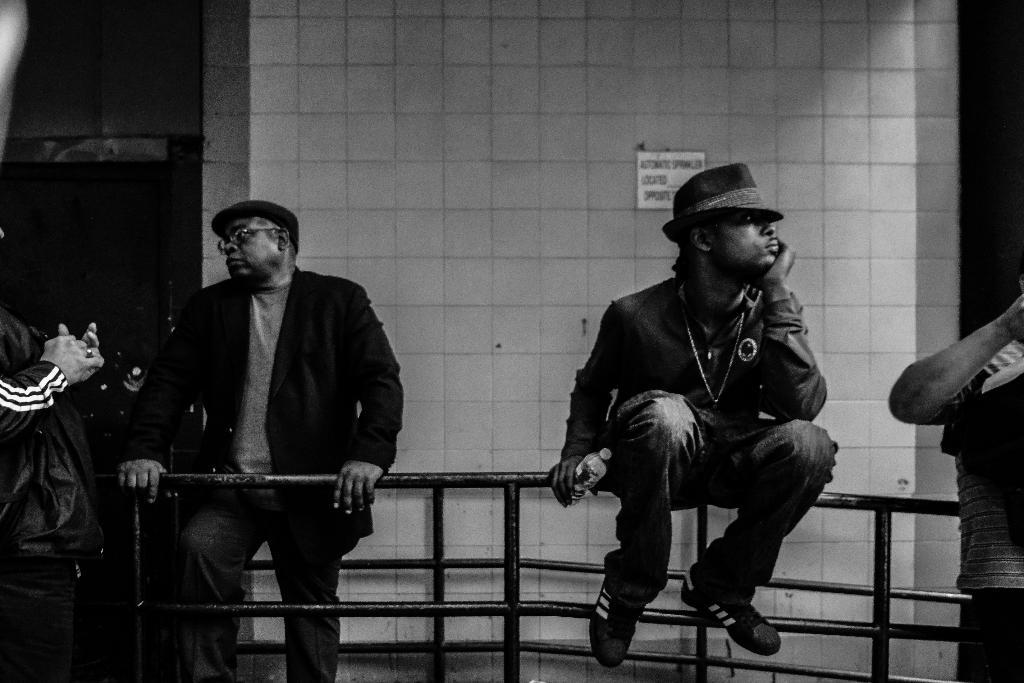Who or what can be seen at the bottom of the image? There are people present at the bottom of the image. What is the person in the middle of the image doing? A person is sitting on a rod in the middle of the image. What can be seen in the background of the image? There is a wall in the background of the image. How many wishes can be granted by the bat in the image? There is no bat present in the image, so it is not possible to grant any wishes. 